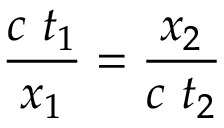Convert formula to latex. <formula><loc_0><loc_0><loc_500><loc_500>{ \frac { c \ t _ { 1 } } { x _ { 1 } } } = { \frac { x _ { 2 } } { c \ t _ { 2 } } }</formula> 